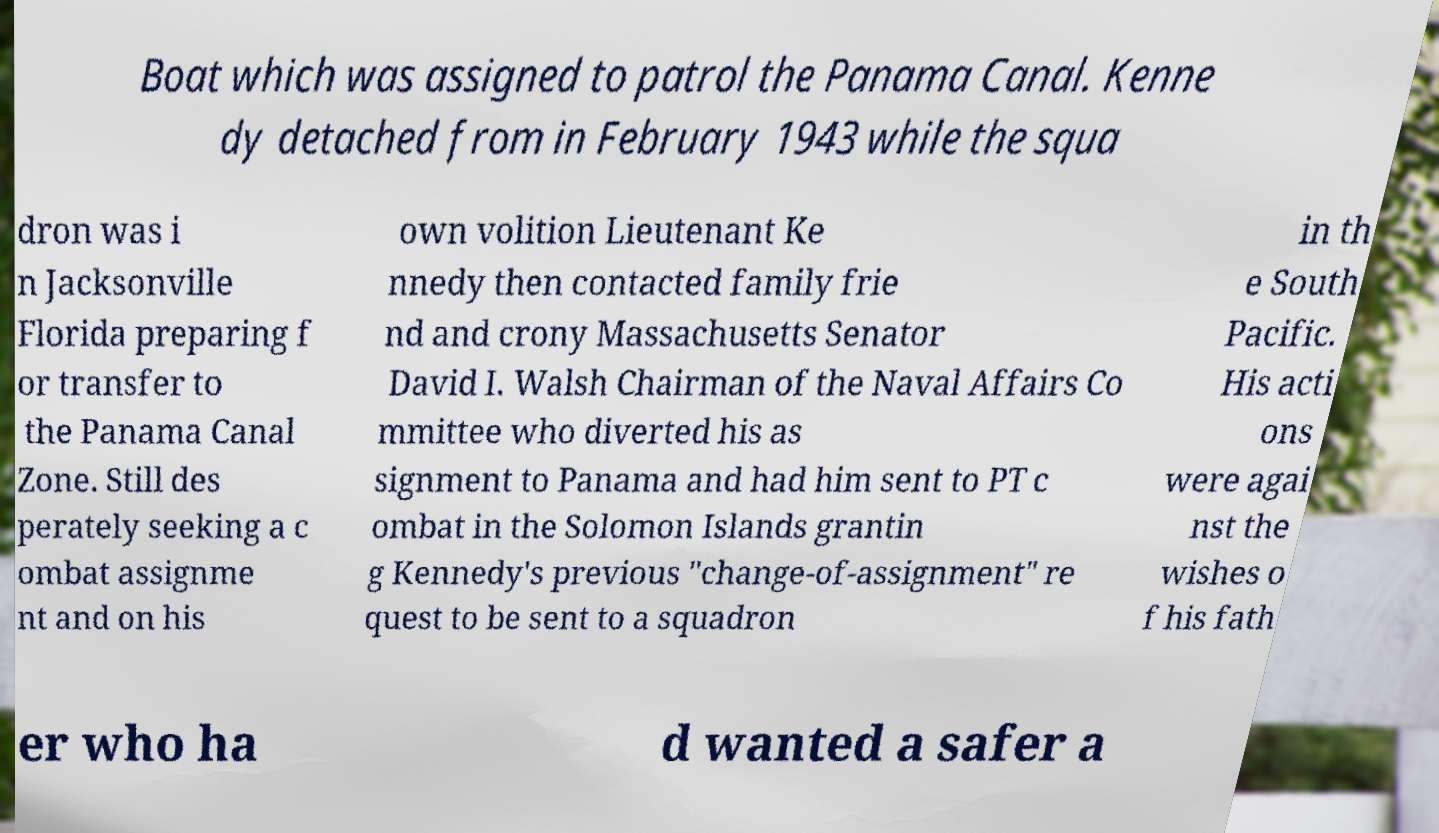Please read and relay the text visible in this image. What does it say? Boat which was assigned to patrol the Panama Canal. Kenne dy detached from in February 1943 while the squa dron was i n Jacksonville Florida preparing f or transfer to the Panama Canal Zone. Still des perately seeking a c ombat assignme nt and on his own volition Lieutenant Ke nnedy then contacted family frie nd and crony Massachusetts Senator David I. Walsh Chairman of the Naval Affairs Co mmittee who diverted his as signment to Panama and had him sent to PT c ombat in the Solomon Islands grantin g Kennedy's previous "change-of-assignment" re quest to be sent to a squadron in th e South Pacific. His acti ons were agai nst the wishes o f his fath er who ha d wanted a safer a 